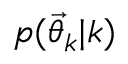Convert formula to latex. <formula><loc_0><loc_0><loc_500><loc_500>p ( { \vec { \theta } } _ { k } | k )</formula> 